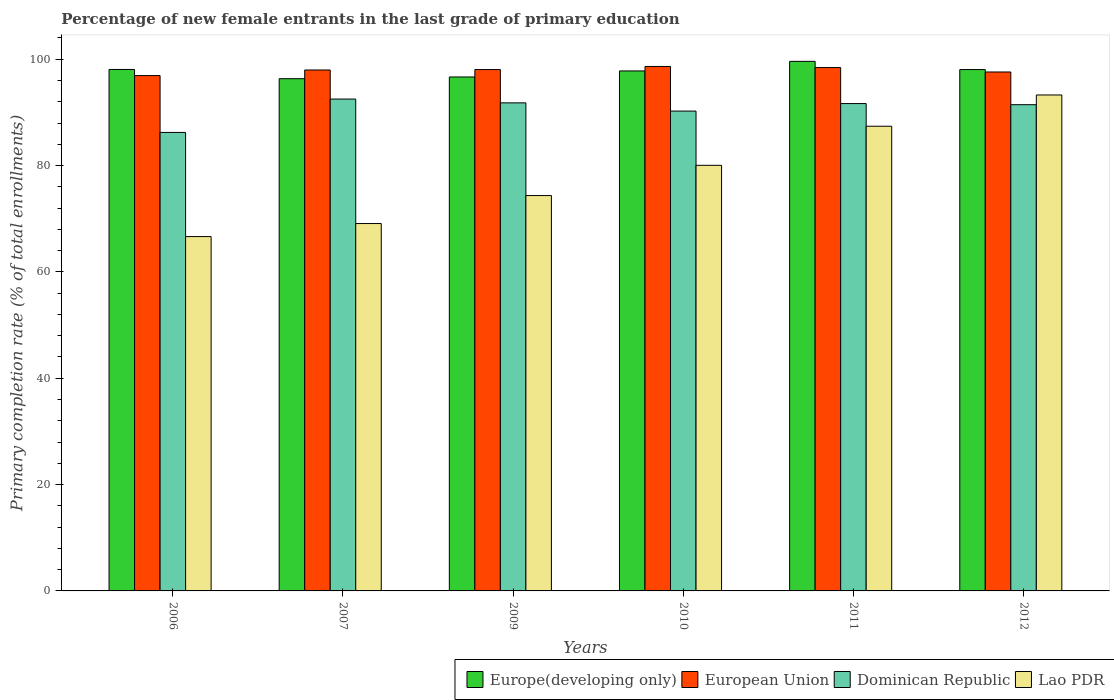How many different coloured bars are there?
Provide a succinct answer. 4. Are the number of bars on each tick of the X-axis equal?
Your response must be concise. Yes. What is the percentage of new female entrants in Lao PDR in 2007?
Ensure brevity in your answer.  69.09. Across all years, what is the maximum percentage of new female entrants in European Union?
Your response must be concise. 98.64. Across all years, what is the minimum percentage of new female entrants in European Union?
Your answer should be compact. 96.92. In which year was the percentage of new female entrants in Europe(developing only) maximum?
Make the answer very short. 2011. In which year was the percentage of new female entrants in Lao PDR minimum?
Give a very brief answer. 2006. What is the total percentage of new female entrants in Lao PDR in the graph?
Provide a succinct answer. 470.8. What is the difference between the percentage of new female entrants in Lao PDR in 2006 and that in 2011?
Give a very brief answer. -20.76. What is the difference between the percentage of new female entrants in European Union in 2011 and the percentage of new female entrants in Dominican Republic in 2012?
Your response must be concise. 6.98. What is the average percentage of new female entrants in Dominican Republic per year?
Offer a very short reply. 90.65. In the year 2007, what is the difference between the percentage of new female entrants in Europe(developing only) and percentage of new female entrants in Dominican Republic?
Your answer should be very brief. 3.83. What is the ratio of the percentage of new female entrants in Europe(developing only) in 2010 to that in 2011?
Ensure brevity in your answer.  0.98. What is the difference between the highest and the second highest percentage of new female entrants in Dominican Republic?
Provide a succinct answer. 0.72. What is the difference between the highest and the lowest percentage of new female entrants in Lao PDR?
Your answer should be compact. 26.63. In how many years, is the percentage of new female entrants in Dominican Republic greater than the average percentage of new female entrants in Dominican Republic taken over all years?
Offer a very short reply. 4. What does the 2nd bar from the left in 2006 represents?
Your answer should be compact. European Union. What does the 4th bar from the right in 2011 represents?
Provide a short and direct response. Europe(developing only). Is it the case that in every year, the sum of the percentage of new female entrants in Dominican Republic and percentage of new female entrants in Europe(developing only) is greater than the percentage of new female entrants in Lao PDR?
Provide a succinct answer. Yes. How many years are there in the graph?
Give a very brief answer. 6. Are the values on the major ticks of Y-axis written in scientific E-notation?
Your answer should be very brief. No. Does the graph contain any zero values?
Keep it short and to the point. No. Where does the legend appear in the graph?
Ensure brevity in your answer.  Bottom right. How are the legend labels stacked?
Provide a short and direct response. Horizontal. What is the title of the graph?
Provide a succinct answer. Percentage of new female entrants in the last grade of primary education. What is the label or title of the Y-axis?
Give a very brief answer. Primary completion rate (% of total enrollments). What is the Primary completion rate (% of total enrollments) of Europe(developing only) in 2006?
Keep it short and to the point. 98.07. What is the Primary completion rate (% of total enrollments) of European Union in 2006?
Your response must be concise. 96.92. What is the Primary completion rate (% of total enrollments) in Dominican Republic in 2006?
Your answer should be very brief. 86.23. What is the Primary completion rate (% of total enrollments) in Lao PDR in 2006?
Keep it short and to the point. 66.64. What is the Primary completion rate (% of total enrollments) of Europe(developing only) in 2007?
Your answer should be very brief. 96.34. What is the Primary completion rate (% of total enrollments) in European Union in 2007?
Your answer should be very brief. 97.97. What is the Primary completion rate (% of total enrollments) in Dominican Republic in 2007?
Offer a terse response. 92.51. What is the Primary completion rate (% of total enrollments) of Lao PDR in 2007?
Offer a terse response. 69.09. What is the Primary completion rate (% of total enrollments) in Europe(developing only) in 2009?
Give a very brief answer. 96.66. What is the Primary completion rate (% of total enrollments) of European Union in 2009?
Keep it short and to the point. 98.05. What is the Primary completion rate (% of total enrollments) in Dominican Republic in 2009?
Provide a succinct answer. 91.79. What is the Primary completion rate (% of total enrollments) in Lao PDR in 2009?
Provide a succinct answer. 74.35. What is the Primary completion rate (% of total enrollments) of Europe(developing only) in 2010?
Give a very brief answer. 97.79. What is the Primary completion rate (% of total enrollments) of European Union in 2010?
Make the answer very short. 98.64. What is the Primary completion rate (% of total enrollments) in Dominican Republic in 2010?
Your response must be concise. 90.25. What is the Primary completion rate (% of total enrollments) in Lao PDR in 2010?
Your answer should be very brief. 80.04. What is the Primary completion rate (% of total enrollments) in Europe(developing only) in 2011?
Your answer should be very brief. 99.6. What is the Primary completion rate (% of total enrollments) in European Union in 2011?
Provide a short and direct response. 98.43. What is the Primary completion rate (% of total enrollments) of Dominican Republic in 2011?
Ensure brevity in your answer.  91.66. What is the Primary completion rate (% of total enrollments) of Lao PDR in 2011?
Make the answer very short. 87.4. What is the Primary completion rate (% of total enrollments) of Europe(developing only) in 2012?
Ensure brevity in your answer.  98.05. What is the Primary completion rate (% of total enrollments) of European Union in 2012?
Keep it short and to the point. 97.6. What is the Primary completion rate (% of total enrollments) in Dominican Republic in 2012?
Your answer should be compact. 91.45. What is the Primary completion rate (% of total enrollments) of Lao PDR in 2012?
Offer a very short reply. 93.27. Across all years, what is the maximum Primary completion rate (% of total enrollments) in Europe(developing only)?
Offer a very short reply. 99.6. Across all years, what is the maximum Primary completion rate (% of total enrollments) in European Union?
Provide a succinct answer. 98.64. Across all years, what is the maximum Primary completion rate (% of total enrollments) of Dominican Republic?
Ensure brevity in your answer.  92.51. Across all years, what is the maximum Primary completion rate (% of total enrollments) in Lao PDR?
Your answer should be very brief. 93.27. Across all years, what is the minimum Primary completion rate (% of total enrollments) of Europe(developing only)?
Keep it short and to the point. 96.34. Across all years, what is the minimum Primary completion rate (% of total enrollments) in European Union?
Offer a terse response. 96.92. Across all years, what is the minimum Primary completion rate (% of total enrollments) of Dominican Republic?
Offer a very short reply. 86.23. Across all years, what is the minimum Primary completion rate (% of total enrollments) of Lao PDR?
Offer a very short reply. 66.64. What is the total Primary completion rate (% of total enrollments) of Europe(developing only) in the graph?
Offer a very short reply. 586.51. What is the total Primary completion rate (% of total enrollments) in European Union in the graph?
Make the answer very short. 587.61. What is the total Primary completion rate (% of total enrollments) of Dominican Republic in the graph?
Your answer should be very brief. 543.88. What is the total Primary completion rate (% of total enrollments) in Lao PDR in the graph?
Your answer should be compact. 470.8. What is the difference between the Primary completion rate (% of total enrollments) in Europe(developing only) in 2006 and that in 2007?
Your answer should be compact. 1.73. What is the difference between the Primary completion rate (% of total enrollments) of European Union in 2006 and that in 2007?
Ensure brevity in your answer.  -1.05. What is the difference between the Primary completion rate (% of total enrollments) of Dominican Republic in 2006 and that in 2007?
Offer a terse response. -6.28. What is the difference between the Primary completion rate (% of total enrollments) in Lao PDR in 2006 and that in 2007?
Keep it short and to the point. -2.45. What is the difference between the Primary completion rate (% of total enrollments) in Europe(developing only) in 2006 and that in 2009?
Provide a succinct answer. 1.41. What is the difference between the Primary completion rate (% of total enrollments) in European Union in 2006 and that in 2009?
Provide a short and direct response. -1.13. What is the difference between the Primary completion rate (% of total enrollments) of Dominican Republic in 2006 and that in 2009?
Your answer should be compact. -5.56. What is the difference between the Primary completion rate (% of total enrollments) in Lao PDR in 2006 and that in 2009?
Make the answer very short. -7.72. What is the difference between the Primary completion rate (% of total enrollments) in Europe(developing only) in 2006 and that in 2010?
Offer a very short reply. 0.28. What is the difference between the Primary completion rate (% of total enrollments) of European Union in 2006 and that in 2010?
Make the answer very short. -1.71. What is the difference between the Primary completion rate (% of total enrollments) of Dominican Republic in 2006 and that in 2010?
Provide a short and direct response. -4.01. What is the difference between the Primary completion rate (% of total enrollments) of Lao PDR in 2006 and that in 2010?
Make the answer very short. -13.41. What is the difference between the Primary completion rate (% of total enrollments) in Europe(developing only) in 2006 and that in 2011?
Give a very brief answer. -1.53. What is the difference between the Primary completion rate (% of total enrollments) in European Union in 2006 and that in 2011?
Keep it short and to the point. -1.51. What is the difference between the Primary completion rate (% of total enrollments) in Dominican Republic in 2006 and that in 2011?
Give a very brief answer. -5.43. What is the difference between the Primary completion rate (% of total enrollments) of Lao PDR in 2006 and that in 2011?
Your response must be concise. -20.76. What is the difference between the Primary completion rate (% of total enrollments) in Europe(developing only) in 2006 and that in 2012?
Ensure brevity in your answer.  0.02. What is the difference between the Primary completion rate (% of total enrollments) of European Union in 2006 and that in 2012?
Make the answer very short. -0.67. What is the difference between the Primary completion rate (% of total enrollments) of Dominican Republic in 2006 and that in 2012?
Provide a short and direct response. -5.21. What is the difference between the Primary completion rate (% of total enrollments) of Lao PDR in 2006 and that in 2012?
Ensure brevity in your answer.  -26.64. What is the difference between the Primary completion rate (% of total enrollments) of Europe(developing only) in 2007 and that in 2009?
Provide a short and direct response. -0.32. What is the difference between the Primary completion rate (% of total enrollments) in European Union in 2007 and that in 2009?
Offer a terse response. -0.08. What is the difference between the Primary completion rate (% of total enrollments) in Dominican Republic in 2007 and that in 2009?
Your response must be concise. 0.72. What is the difference between the Primary completion rate (% of total enrollments) of Lao PDR in 2007 and that in 2009?
Make the answer very short. -5.26. What is the difference between the Primary completion rate (% of total enrollments) in Europe(developing only) in 2007 and that in 2010?
Your answer should be compact. -1.46. What is the difference between the Primary completion rate (% of total enrollments) of European Union in 2007 and that in 2010?
Provide a succinct answer. -0.67. What is the difference between the Primary completion rate (% of total enrollments) of Dominican Republic in 2007 and that in 2010?
Your answer should be very brief. 2.26. What is the difference between the Primary completion rate (% of total enrollments) of Lao PDR in 2007 and that in 2010?
Your answer should be compact. -10.95. What is the difference between the Primary completion rate (% of total enrollments) of Europe(developing only) in 2007 and that in 2011?
Your answer should be very brief. -3.26. What is the difference between the Primary completion rate (% of total enrollments) in European Union in 2007 and that in 2011?
Offer a very short reply. -0.46. What is the difference between the Primary completion rate (% of total enrollments) in Dominican Republic in 2007 and that in 2011?
Offer a very short reply. 0.85. What is the difference between the Primary completion rate (% of total enrollments) in Lao PDR in 2007 and that in 2011?
Make the answer very short. -18.3. What is the difference between the Primary completion rate (% of total enrollments) in Europe(developing only) in 2007 and that in 2012?
Offer a very short reply. -1.72. What is the difference between the Primary completion rate (% of total enrollments) of European Union in 2007 and that in 2012?
Provide a short and direct response. 0.37. What is the difference between the Primary completion rate (% of total enrollments) in Dominican Republic in 2007 and that in 2012?
Offer a terse response. 1.06. What is the difference between the Primary completion rate (% of total enrollments) in Lao PDR in 2007 and that in 2012?
Your response must be concise. -24.18. What is the difference between the Primary completion rate (% of total enrollments) of Europe(developing only) in 2009 and that in 2010?
Provide a succinct answer. -1.13. What is the difference between the Primary completion rate (% of total enrollments) in European Union in 2009 and that in 2010?
Offer a terse response. -0.59. What is the difference between the Primary completion rate (% of total enrollments) in Dominican Republic in 2009 and that in 2010?
Your answer should be compact. 1.54. What is the difference between the Primary completion rate (% of total enrollments) in Lao PDR in 2009 and that in 2010?
Provide a short and direct response. -5.69. What is the difference between the Primary completion rate (% of total enrollments) in Europe(developing only) in 2009 and that in 2011?
Provide a succinct answer. -2.94. What is the difference between the Primary completion rate (% of total enrollments) of European Union in 2009 and that in 2011?
Offer a very short reply. -0.38. What is the difference between the Primary completion rate (% of total enrollments) in Dominican Republic in 2009 and that in 2011?
Your answer should be compact. 0.13. What is the difference between the Primary completion rate (% of total enrollments) of Lao PDR in 2009 and that in 2011?
Provide a succinct answer. -13.04. What is the difference between the Primary completion rate (% of total enrollments) of Europe(developing only) in 2009 and that in 2012?
Provide a short and direct response. -1.39. What is the difference between the Primary completion rate (% of total enrollments) of European Union in 2009 and that in 2012?
Keep it short and to the point. 0.45. What is the difference between the Primary completion rate (% of total enrollments) of Dominican Republic in 2009 and that in 2012?
Make the answer very short. 0.34. What is the difference between the Primary completion rate (% of total enrollments) in Lao PDR in 2009 and that in 2012?
Make the answer very short. -18.92. What is the difference between the Primary completion rate (% of total enrollments) of Europe(developing only) in 2010 and that in 2011?
Your answer should be compact. -1.81. What is the difference between the Primary completion rate (% of total enrollments) of European Union in 2010 and that in 2011?
Provide a short and direct response. 0.21. What is the difference between the Primary completion rate (% of total enrollments) of Dominican Republic in 2010 and that in 2011?
Offer a very short reply. -1.41. What is the difference between the Primary completion rate (% of total enrollments) of Lao PDR in 2010 and that in 2011?
Make the answer very short. -7.35. What is the difference between the Primary completion rate (% of total enrollments) in Europe(developing only) in 2010 and that in 2012?
Your answer should be very brief. -0.26. What is the difference between the Primary completion rate (% of total enrollments) of European Union in 2010 and that in 2012?
Keep it short and to the point. 1.04. What is the difference between the Primary completion rate (% of total enrollments) of Dominican Republic in 2010 and that in 2012?
Ensure brevity in your answer.  -1.2. What is the difference between the Primary completion rate (% of total enrollments) of Lao PDR in 2010 and that in 2012?
Your answer should be very brief. -13.23. What is the difference between the Primary completion rate (% of total enrollments) of Europe(developing only) in 2011 and that in 2012?
Give a very brief answer. 1.54. What is the difference between the Primary completion rate (% of total enrollments) of European Union in 2011 and that in 2012?
Your answer should be very brief. 0.83. What is the difference between the Primary completion rate (% of total enrollments) of Dominican Republic in 2011 and that in 2012?
Your response must be concise. 0.21. What is the difference between the Primary completion rate (% of total enrollments) in Lao PDR in 2011 and that in 2012?
Offer a terse response. -5.88. What is the difference between the Primary completion rate (% of total enrollments) of Europe(developing only) in 2006 and the Primary completion rate (% of total enrollments) of European Union in 2007?
Keep it short and to the point. 0.1. What is the difference between the Primary completion rate (% of total enrollments) in Europe(developing only) in 2006 and the Primary completion rate (% of total enrollments) in Dominican Republic in 2007?
Ensure brevity in your answer.  5.56. What is the difference between the Primary completion rate (% of total enrollments) in Europe(developing only) in 2006 and the Primary completion rate (% of total enrollments) in Lao PDR in 2007?
Your answer should be very brief. 28.98. What is the difference between the Primary completion rate (% of total enrollments) of European Union in 2006 and the Primary completion rate (% of total enrollments) of Dominican Republic in 2007?
Provide a short and direct response. 4.42. What is the difference between the Primary completion rate (% of total enrollments) of European Union in 2006 and the Primary completion rate (% of total enrollments) of Lao PDR in 2007?
Offer a very short reply. 27.83. What is the difference between the Primary completion rate (% of total enrollments) in Dominican Republic in 2006 and the Primary completion rate (% of total enrollments) in Lao PDR in 2007?
Make the answer very short. 17.14. What is the difference between the Primary completion rate (% of total enrollments) in Europe(developing only) in 2006 and the Primary completion rate (% of total enrollments) in European Union in 2009?
Ensure brevity in your answer.  0.02. What is the difference between the Primary completion rate (% of total enrollments) of Europe(developing only) in 2006 and the Primary completion rate (% of total enrollments) of Dominican Republic in 2009?
Make the answer very short. 6.28. What is the difference between the Primary completion rate (% of total enrollments) in Europe(developing only) in 2006 and the Primary completion rate (% of total enrollments) in Lao PDR in 2009?
Provide a short and direct response. 23.72. What is the difference between the Primary completion rate (% of total enrollments) in European Union in 2006 and the Primary completion rate (% of total enrollments) in Dominican Republic in 2009?
Offer a very short reply. 5.13. What is the difference between the Primary completion rate (% of total enrollments) of European Union in 2006 and the Primary completion rate (% of total enrollments) of Lao PDR in 2009?
Ensure brevity in your answer.  22.57. What is the difference between the Primary completion rate (% of total enrollments) in Dominican Republic in 2006 and the Primary completion rate (% of total enrollments) in Lao PDR in 2009?
Offer a terse response. 11.88. What is the difference between the Primary completion rate (% of total enrollments) in Europe(developing only) in 2006 and the Primary completion rate (% of total enrollments) in European Union in 2010?
Provide a succinct answer. -0.57. What is the difference between the Primary completion rate (% of total enrollments) of Europe(developing only) in 2006 and the Primary completion rate (% of total enrollments) of Dominican Republic in 2010?
Give a very brief answer. 7.83. What is the difference between the Primary completion rate (% of total enrollments) of Europe(developing only) in 2006 and the Primary completion rate (% of total enrollments) of Lao PDR in 2010?
Give a very brief answer. 18.03. What is the difference between the Primary completion rate (% of total enrollments) in European Union in 2006 and the Primary completion rate (% of total enrollments) in Dominican Republic in 2010?
Keep it short and to the point. 6.68. What is the difference between the Primary completion rate (% of total enrollments) in European Union in 2006 and the Primary completion rate (% of total enrollments) in Lao PDR in 2010?
Your answer should be very brief. 16.88. What is the difference between the Primary completion rate (% of total enrollments) of Dominican Republic in 2006 and the Primary completion rate (% of total enrollments) of Lao PDR in 2010?
Your answer should be very brief. 6.19. What is the difference between the Primary completion rate (% of total enrollments) of Europe(developing only) in 2006 and the Primary completion rate (% of total enrollments) of European Union in 2011?
Offer a terse response. -0.36. What is the difference between the Primary completion rate (% of total enrollments) in Europe(developing only) in 2006 and the Primary completion rate (% of total enrollments) in Dominican Republic in 2011?
Offer a terse response. 6.41. What is the difference between the Primary completion rate (% of total enrollments) in Europe(developing only) in 2006 and the Primary completion rate (% of total enrollments) in Lao PDR in 2011?
Ensure brevity in your answer.  10.68. What is the difference between the Primary completion rate (% of total enrollments) of European Union in 2006 and the Primary completion rate (% of total enrollments) of Dominican Republic in 2011?
Give a very brief answer. 5.27. What is the difference between the Primary completion rate (% of total enrollments) of European Union in 2006 and the Primary completion rate (% of total enrollments) of Lao PDR in 2011?
Ensure brevity in your answer.  9.53. What is the difference between the Primary completion rate (% of total enrollments) of Dominican Republic in 2006 and the Primary completion rate (% of total enrollments) of Lao PDR in 2011?
Keep it short and to the point. -1.16. What is the difference between the Primary completion rate (% of total enrollments) in Europe(developing only) in 2006 and the Primary completion rate (% of total enrollments) in European Union in 2012?
Provide a short and direct response. 0.47. What is the difference between the Primary completion rate (% of total enrollments) in Europe(developing only) in 2006 and the Primary completion rate (% of total enrollments) in Dominican Republic in 2012?
Ensure brevity in your answer.  6.62. What is the difference between the Primary completion rate (% of total enrollments) in Europe(developing only) in 2006 and the Primary completion rate (% of total enrollments) in Lao PDR in 2012?
Provide a short and direct response. 4.8. What is the difference between the Primary completion rate (% of total enrollments) of European Union in 2006 and the Primary completion rate (% of total enrollments) of Dominican Republic in 2012?
Provide a succinct answer. 5.48. What is the difference between the Primary completion rate (% of total enrollments) in European Union in 2006 and the Primary completion rate (% of total enrollments) in Lao PDR in 2012?
Your answer should be compact. 3.65. What is the difference between the Primary completion rate (% of total enrollments) in Dominican Republic in 2006 and the Primary completion rate (% of total enrollments) in Lao PDR in 2012?
Offer a very short reply. -7.04. What is the difference between the Primary completion rate (% of total enrollments) of Europe(developing only) in 2007 and the Primary completion rate (% of total enrollments) of European Union in 2009?
Provide a succinct answer. -1.71. What is the difference between the Primary completion rate (% of total enrollments) of Europe(developing only) in 2007 and the Primary completion rate (% of total enrollments) of Dominican Republic in 2009?
Provide a short and direct response. 4.55. What is the difference between the Primary completion rate (% of total enrollments) in Europe(developing only) in 2007 and the Primary completion rate (% of total enrollments) in Lao PDR in 2009?
Ensure brevity in your answer.  21.98. What is the difference between the Primary completion rate (% of total enrollments) in European Union in 2007 and the Primary completion rate (% of total enrollments) in Dominican Republic in 2009?
Your answer should be compact. 6.18. What is the difference between the Primary completion rate (% of total enrollments) in European Union in 2007 and the Primary completion rate (% of total enrollments) in Lao PDR in 2009?
Your answer should be compact. 23.62. What is the difference between the Primary completion rate (% of total enrollments) of Dominican Republic in 2007 and the Primary completion rate (% of total enrollments) of Lao PDR in 2009?
Keep it short and to the point. 18.15. What is the difference between the Primary completion rate (% of total enrollments) of Europe(developing only) in 2007 and the Primary completion rate (% of total enrollments) of European Union in 2010?
Ensure brevity in your answer.  -2.3. What is the difference between the Primary completion rate (% of total enrollments) of Europe(developing only) in 2007 and the Primary completion rate (% of total enrollments) of Dominican Republic in 2010?
Your answer should be very brief. 6.09. What is the difference between the Primary completion rate (% of total enrollments) in Europe(developing only) in 2007 and the Primary completion rate (% of total enrollments) in Lao PDR in 2010?
Give a very brief answer. 16.29. What is the difference between the Primary completion rate (% of total enrollments) of European Union in 2007 and the Primary completion rate (% of total enrollments) of Dominican Republic in 2010?
Your answer should be very brief. 7.73. What is the difference between the Primary completion rate (% of total enrollments) of European Union in 2007 and the Primary completion rate (% of total enrollments) of Lao PDR in 2010?
Give a very brief answer. 17.93. What is the difference between the Primary completion rate (% of total enrollments) of Dominican Republic in 2007 and the Primary completion rate (% of total enrollments) of Lao PDR in 2010?
Provide a short and direct response. 12.46. What is the difference between the Primary completion rate (% of total enrollments) in Europe(developing only) in 2007 and the Primary completion rate (% of total enrollments) in European Union in 2011?
Provide a succinct answer. -2.09. What is the difference between the Primary completion rate (% of total enrollments) in Europe(developing only) in 2007 and the Primary completion rate (% of total enrollments) in Dominican Republic in 2011?
Give a very brief answer. 4.68. What is the difference between the Primary completion rate (% of total enrollments) of Europe(developing only) in 2007 and the Primary completion rate (% of total enrollments) of Lao PDR in 2011?
Provide a short and direct response. 8.94. What is the difference between the Primary completion rate (% of total enrollments) of European Union in 2007 and the Primary completion rate (% of total enrollments) of Dominican Republic in 2011?
Your response must be concise. 6.31. What is the difference between the Primary completion rate (% of total enrollments) of European Union in 2007 and the Primary completion rate (% of total enrollments) of Lao PDR in 2011?
Provide a short and direct response. 10.58. What is the difference between the Primary completion rate (% of total enrollments) of Dominican Republic in 2007 and the Primary completion rate (% of total enrollments) of Lao PDR in 2011?
Make the answer very short. 5.11. What is the difference between the Primary completion rate (% of total enrollments) of Europe(developing only) in 2007 and the Primary completion rate (% of total enrollments) of European Union in 2012?
Your answer should be compact. -1.26. What is the difference between the Primary completion rate (% of total enrollments) of Europe(developing only) in 2007 and the Primary completion rate (% of total enrollments) of Dominican Republic in 2012?
Offer a terse response. 4.89. What is the difference between the Primary completion rate (% of total enrollments) in Europe(developing only) in 2007 and the Primary completion rate (% of total enrollments) in Lao PDR in 2012?
Keep it short and to the point. 3.06. What is the difference between the Primary completion rate (% of total enrollments) in European Union in 2007 and the Primary completion rate (% of total enrollments) in Dominican Republic in 2012?
Your answer should be very brief. 6.53. What is the difference between the Primary completion rate (% of total enrollments) in European Union in 2007 and the Primary completion rate (% of total enrollments) in Lao PDR in 2012?
Give a very brief answer. 4.7. What is the difference between the Primary completion rate (% of total enrollments) of Dominican Republic in 2007 and the Primary completion rate (% of total enrollments) of Lao PDR in 2012?
Provide a succinct answer. -0.77. What is the difference between the Primary completion rate (% of total enrollments) of Europe(developing only) in 2009 and the Primary completion rate (% of total enrollments) of European Union in 2010?
Your response must be concise. -1.98. What is the difference between the Primary completion rate (% of total enrollments) of Europe(developing only) in 2009 and the Primary completion rate (% of total enrollments) of Dominican Republic in 2010?
Your answer should be very brief. 6.41. What is the difference between the Primary completion rate (% of total enrollments) in Europe(developing only) in 2009 and the Primary completion rate (% of total enrollments) in Lao PDR in 2010?
Keep it short and to the point. 16.61. What is the difference between the Primary completion rate (% of total enrollments) of European Union in 2009 and the Primary completion rate (% of total enrollments) of Dominican Republic in 2010?
Your response must be concise. 7.81. What is the difference between the Primary completion rate (% of total enrollments) of European Union in 2009 and the Primary completion rate (% of total enrollments) of Lao PDR in 2010?
Provide a short and direct response. 18.01. What is the difference between the Primary completion rate (% of total enrollments) in Dominican Republic in 2009 and the Primary completion rate (% of total enrollments) in Lao PDR in 2010?
Your answer should be compact. 11.74. What is the difference between the Primary completion rate (% of total enrollments) of Europe(developing only) in 2009 and the Primary completion rate (% of total enrollments) of European Union in 2011?
Your response must be concise. -1.77. What is the difference between the Primary completion rate (% of total enrollments) of Europe(developing only) in 2009 and the Primary completion rate (% of total enrollments) of Dominican Republic in 2011?
Offer a very short reply. 5. What is the difference between the Primary completion rate (% of total enrollments) in Europe(developing only) in 2009 and the Primary completion rate (% of total enrollments) in Lao PDR in 2011?
Ensure brevity in your answer.  9.26. What is the difference between the Primary completion rate (% of total enrollments) in European Union in 2009 and the Primary completion rate (% of total enrollments) in Dominican Republic in 2011?
Your answer should be very brief. 6.39. What is the difference between the Primary completion rate (% of total enrollments) of European Union in 2009 and the Primary completion rate (% of total enrollments) of Lao PDR in 2011?
Your answer should be compact. 10.66. What is the difference between the Primary completion rate (% of total enrollments) in Dominican Republic in 2009 and the Primary completion rate (% of total enrollments) in Lao PDR in 2011?
Your response must be concise. 4.39. What is the difference between the Primary completion rate (% of total enrollments) of Europe(developing only) in 2009 and the Primary completion rate (% of total enrollments) of European Union in 2012?
Offer a very short reply. -0.94. What is the difference between the Primary completion rate (% of total enrollments) in Europe(developing only) in 2009 and the Primary completion rate (% of total enrollments) in Dominican Republic in 2012?
Offer a very short reply. 5.21. What is the difference between the Primary completion rate (% of total enrollments) in Europe(developing only) in 2009 and the Primary completion rate (% of total enrollments) in Lao PDR in 2012?
Keep it short and to the point. 3.38. What is the difference between the Primary completion rate (% of total enrollments) in European Union in 2009 and the Primary completion rate (% of total enrollments) in Dominican Republic in 2012?
Offer a very short reply. 6.61. What is the difference between the Primary completion rate (% of total enrollments) in European Union in 2009 and the Primary completion rate (% of total enrollments) in Lao PDR in 2012?
Your answer should be compact. 4.78. What is the difference between the Primary completion rate (% of total enrollments) in Dominican Republic in 2009 and the Primary completion rate (% of total enrollments) in Lao PDR in 2012?
Offer a very short reply. -1.49. What is the difference between the Primary completion rate (% of total enrollments) in Europe(developing only) in 2010 and the Primary completion rate (% of total enrollments) in European Union in 2011?
Your answer should be compact. -0.64. What is the difference between the Primary completion rate (% of total enrollments) in Europe(developing only) in 2010 and the Primary completion rate (% of total enrollments) in Dominican Republic in 2011?
Make the answer very short. 6.13. What is the difference between the Primary completion rate (% of total enrollments) in Europe(developing only) in 2010 and the Primary completion rate (% of total enrollments) in Lao PDR in 2011?
Your answer should be very brief. 10.4. What is the difference between the Primary completion rate (% of total enrollments) in European Union in 2010 and the Primary completion rate (% of total enrollments) in Dominican Republic in 2011?
Your response must be concise. 6.98. What is the difference between the Primary completion rate (% of total enrollments) in European Union in 2010 and the Primary completion rate (% of total enrollments) in Lao PDR in 2011?
Provide a succinct answer. 11.24. What is the difference between the Primary completion rate (% of total enrollments) of Dominican Republic in 2010 and the Primary completion rate (% of total enrollments) of Lao PDR in 2011?
Offer a terse response. 2.85. What is the difference between the Primary completion rate (% of total enrollments) of Europe(developing only) in 2010 and the Primary completion rate (% of total enrollments) of European Union in 2012?
Your answer should be very brief. 0.19. What is the difference between the Primary completion rate (% of total enrollments) of Europe(developing only) in 2010 and the Primary completion rate (% of total enrollments) of Dominican Republic in 2012?
Provide a short and direct response. 6.35. What is the difference between the Primary completion rate (% of total enrollments) of Europe(developing only) in 2010 and the Primary completion rate (% of total enrollments) of Lao PDR in 2012?
Make the answer very short. 4.52. What is the difference between the Primary completion rate (% of total enrollments) of European Union in 2010 and the Primary completion rate (% of total enrollments) of Dominican Republic in 2012?
Your answer should be very brief. 7.19. What is the difference between the Primary completion rate (% of total enrollments) in European Union in 2010 and the Primary completion rate (% of total enrollments) in Lao PDR in 2012?
Your response must be concise. 5.36. What is the difference between the Primary completion rate (% of total enrollments) in Dominican Republic in 2010 and the Primary completion rate (% of total enrollments) in Lao PDR in 2012?
Your response must be concise. -3.03. What is the difference between the Primary completion rate (% of total enrollments) in Europe(developing only) in 2011 and the Primary completion rate (% of total enrollments) in European Union in 2012?
Provide a succinct answer. 2. What is the difference between the Primary completion rate (% of total enrollments) of Europe(developing only) in 2011 and the Primary completion rate (% of total enrollments) of Dominican Republic in 2012?
Give a very brief answer. 8.15. What is the difference between the Primary completion rate (% of total enrollments) of Europe(developing only) in 2011 and the Primary completion rate (% of total enrollments) of Lao PDR in 2012?
Provide a succinct answer. 6.32. What is the difference between the Primary completion rate (% of total enrollments) in European Union in 2011 and the Primary completion rate (% of total enrollments) in Dominican Republic in 2012?
Your answer should be very brief. 6.98. What is the difference between the Primary completion rate (% of total enrollments) of European Union in 2011 and the Primary completion rate (% of total enrollments) of Lao PDR in 2012?
Give a very brief answer. 5.16. What is the difference between the Primary completion rate (% of total enrollments) in Dominican Republic in 2011 and the Primary completion rate (% of total enrollments) in Lao PDR in 2012?
Offer a very short reply. -1.62. What is the average Primary completion rate (% of total enrollments) of Europe(developing only) per year?
Offer a terse response. 97.75. What is the average Primary completion rate (% of total enrollments) of European Union per year?
Give a very brief answer. 97.94. What is the average Primary completion rate (% of total enrollments) in Dominican Republic per year?
Your answer should be compact. 90.65. What is the average Primary completion rate (% of total enrollments) of Lao PDR per year?
Make the answer very short. 78.47. In the year 2006, what is the difference between the Primary completion rate (% of total enrollments) of Europe(developing only) and Primary completion rate (% of total enrollments) of European Union?
Your answer should be very brief. 1.15. In the year 2006, what is the difference between the Primary completion rate (% of total enrollments) of Europe(developing only) and Primary completion rate (% of total enrollments) of Dominican Republic?
Offer a terse response. 11.84. In the year 2006, what is the difference between the Primary completion rate (% of total enrollments) of Europe(developing only) and Primary completion rate (% of total enrollments) of Lao PDR?
Provide a short and direct response. 31.43. In the year 2006, what is the difference between the Primary completion rate (% of total enrollments) of European Union and Primary completion rate (% of total enrollments) of Dominican Republic?
Your response must be concise. 10.69. In the year 2006, what is the difference between the Primary completion rate (% of total enrollments) in European Union and Primary completion rate (% of total enrollments) in Lao PDR?
Your response must be concise. 30.28. In the year 2006, what is the difference between the Primary completion rate (% of total enrollments) in Dominican Republic and Primary completion rate (% of total enrollments) in Lao PDR?
Ensure brevity in your answer.  19.59. In the year 2007, what is the difference between the Primary completion rate (% of total enrollments) in Europe(developing only) and Primary completion rate (% of total enrollments) in European Union?
Provide a succinct answer. -1.64. In the year 2007, what is the difference between the Primary completion rate (% of total enrollments) of Europe(developing only) and Primary completion rate (% of total enrollments) of Dominican Republic?
Your response must be concise. 3.83. In the year 2007, what is the difference between the Primary completion rate (% of total enrollments) in Europe(developing only) and Primary completion rate (% of total enrollments) in Lao PDR?
Keep it short and to the point. 27.24. In the year 2007, what is the difference between the Primary completion rate (% of total enrollments) in European Union and Primary completion rate (% of total enrollments) in Dominican Republic?
Give a very brief answer. 5.46. In the year 2007, what is the difference between the Primary completion rate (% of total enrollments) in European Union and Primary completion rate (% of total enrollments) in Lao PDR?
Give a very brief answer. 28.88. In the year 2007, what is the difference between the Primary completion rate (% of total enrollments) in Dominican Republic and Primary completion rate (% of total enrollments) in Lao PDR?
Make the answer very short. 23.41. In the year 2009, what is the difference between the Primary completion rate (% of total enrollments) of Europe(developing only) and Primary completion rate (% of total enrollments) of European Union?
Offer a terse response. -1.39. In the year 2009, what is the difference between the Primary completion rate (% of total enrollments) in Europe(developing only) and Primary completion rate (% of total enrollments) in Dominican Republic?
Offer a terse response. 4.87. In the year 2009, what is the difference between the Primary completion rate (% of total enrollments) of Europe(developing only) and Primary completion rate (% of total enrollments) of Lao PDR?
Ensure brevity in your answer.  22.3. In the year 2009, what is the difference between the Primary completion rate (% of total enrollments) in European Union and Primary completion rate (% of total enrollments) in Dominican Republic?
Offer a very short reply. 6.26. In the year 2009, what is the difference between the Primary completion rate (% of total enrollments) in European Union and Primary completion rate (% of total enrollments) in Lao PDR?
Make the answer very short. 23.7. In the year 2009, what is the difference between the Primary completion rate (% of total enrollments) in Dominican Republic and Primary completion rate (% of total enrollments) in Lao PDR?
Provide a short and direct response. 17.43. In the year 2010, what is the difference between the Primary completion rate (% of total enrollments) of Europe(developing only) and Primary completion rate (% of total enrollments) of European Union?
Your response must be concise. -0.85. In the year 2010, what is the difference between the Primary completion rate (% of total enrollments) of Europe(developing only) and Primary completion rate (% of total enrollments) of Dominican Republic?
Provide a succinct answer. 7.55. In the year 2010, what is the difference between the Primary completion rate (% of total enrollments) of Europe(developing only) and Primary completion rate (% of total enrollments) of Lao PDR?
Your answer should be compact. 17.75. In the year 2010, what is the difference between the Primary completion rate (% of total enrollments) in European Union and Primary completion rate (% of total enrollments) in Dominican Republic?
Your answer should be very brief. 8.39. In the year 2010, what is the difference between the Primary completion rate (% of total enrollments) in European Union and Primary completion rate (% of total enrollments) in Lao PDR?
Keep it short and to the point. 18.59. In the year 2010, what is the difference between the Primary completion rate (% of total enrollments) in Dominican Republic and Primary completion rate (% of total enrollments) in Lao PDR?
Make the answer very short. 10.2. In the year 2011, what is the difference between the Primary completion rate (% of total enrollments) in Europe(developing only) and Primary completion rate (% of total enrollments) in European Union?
Your answer should be very brief. 1.17. In the year 2011, what is the difference between the Primary completion rate (% of total enrollments) in Europe(developing only) and Primary completion rate (% of total enrollments) in Dominican Republic?
Your response must be concise. 7.94. In the year 2011, what is the difference between the Primary completion rate (% of total enrollments) in Europe(developing only) and Primary completion rate (% of total enrollments) in Lao PDR?
Give a very brief answer. 12.2. In the year 2011, what is the difference between the Primary completion rate (% of total enrollments) of European Union and Primary completion rate (% of total enrollments) of Dominican Republic?
Offer a terse response. 6.77. In the year 2011, what is the difference between the Primary completion rate (% of total enrollments) of European Union and Primary completion rate (% of total enrollments) of Lao PDR?
Your answer should be compact. 11.04. In the year 2011, what is the difference between the Primary completion rate (% of total enrollments) in Dominican Republic and Primary completion rate (% of total enrollments) in Lao PDR?
Ensure brevity in your answer.  4.26. In the year 2012, what is the difference between the Primary completion rate (% of total enrollments) of Europe(developing only) and Primary completion rate (% of total enrollments) of European Union?
Your answer should be very brief. 0.46. In the year 2012, what is the difference between the Primary completion rate (% of total enrollments) of Europe(developing only) and Primary completion rate (% of total enrollments) of Dominican Republic?
Ensure brevity in your answer.  6.61. In the year 2012, what is the difference between the Primary completion rate (% of total enrollments) in Europe(developing only) and Primary completion rate (% of total enrollments) in Lao PDR?
Keep it short and to the point. 4.78. In the year 2012, what is the difference between the Primary completion rate (% of total enrollments) of European Union and Primary completion rate (% of total enrollments) of Dominican Republic?
Make the answer very short. 6.15. In the year 2012, what is the difference between the Primary completion rate (% of total enrollments) in European Union and Primary completion rate (% of total enrollments) in Lao PDR?
Make the answer very short. 4.32. In the year 2012, what is the difference between the Primary completion rate (% of total enrollments) of Dominican Republic and Primary completion rate (% of total enrollments) of Lao PDR?
Your answer should be compact. -1.83. What is the ratio of the Primary completion rate (% of total enrollments) of Europe(developing only) in 2006 to that in 2007?
Offer a very short reply. 1.02. What is the ratio of the Primary completion rate (% of total enrollments) of European Union in 2006 to that in 2007?
Your response must be concise. 0.99. What is the ratio of the Primary completion rate (% of total enrollments) in Dominican Republic in 2006 to that in 2007?
Keep it short and to the point. 0.93. What is the ratio of the Primary completion rate (% of total enrollments) in Lao PDR in 2006 to that in 2007?
Provide a succinct answer. 0.96. What is the ratio of the Primary completion rate (% of total enrollments) in Europe(developing only) in 2006 to that in 2009?
Offer a terse response. 1.01. What is the ratio of the Primary completion rate (% of total enrollments) of Dominican Republic in 2006 to that in 2009?
Keep it short and to the point. 0.94. What is the ratio of the Primary completion rate (% of total enrollments) in Lao PDR in 2006 to that in 2009?
Offer a very short reply. 0.9. What is the ratio of the Primary completion rate (% of total enrollments) of European Union in 2006 to that in 2010?
Provide a succinct answer. 0.98. What is the ratio of the Primary completion rate (% of total enrollments) of Dominican Republic in 2006 to that in 2010?
Provide a short and direct response. 0.96. What is the ratio of the Primary completion rate (% of total enrollments) of Lao PDR in 2006 to that in 2010?
Ensure brevity in your answer.  0.83. What is the ratio of the Primary completion rate (% of total enrollments) of Europe(developing only) in 2006 to that in 2011?
Make the answer very short. 0.98. What is the ratio of the Primary completion rate (% of total enrollments) in European Union in 2006 to that in 2011?
Provide a succinct answer. 0.98. What is the ratio of the Primary completion rate (% of total enrollments) of Dominican Republic in 2006 to that in 2011?
Offer a very short reply. 0.94. What is the ratio of the Primary completion rate (% of total enrollments) of Lao PDR in 2006 to that in 2011?
Your answer should be compact. 0.76. What is the ratio of the Primary completion rate (% of total enrollments) of Dominican Republic in 2006 to that in 2012?
Provide a short and direct response. 0.94. What is the ratio of the Primary completion rate (% of total enrollments) in Lao PDR in 2006 to that in 2012?
Your answer should be compact. 0.71. What is the ratio of the Primary completion rate (% of total enrollments) in Europe(developing only) in 2007 to that in 2009?
Make the answer very short. 1. What is the ratio of the Primary completion rate (% of total enrollments) in Lao PDR in 2007 to that in 2009?
Offer a terse response. 0.93. What is the ratio of the Primary completion rate (% of total enrollments) of Europe(developing only) in 2007 to that in 2010?
Offer a very short reply. 0.99. What is the ratio of the Primary completion rate (% of total enrollments) in Dominican Republic in 2007 to that in 2010?
Offer a very short reply. 1.03. What is the ratio of the Primary completion rate (% of total enrollments) of Lao PDR in 2007 to that in 2010?
Give a very brief answer. 0.86. What is the ratio of the Primary completion rate (% of total enrollments) in Europe(developing only) in 2007 to that in 2011?
Keep it short and to the point. 0.97. What is the ratio of the Primary completion rate (% of total enrollments) in Dominican Republic in 2007 to that in 2011?
Provide a short and direct response. 1.01. What is the ratio of the Primary completion rate (% of total enrollments) in Lao PDR in 2007 to that in 2011?
Make the answer very short. 0.79. What is the ratio of the Primary completion rate (% of total enrollments) in Europe(developing only) in 2007 to that in 2012?
Ensure brevity in your answer.  0.98. What is the ratio of the Primary completion rate (% of total enrollments) in Dominican Republic in 2007 to that in 2012?
Ensure brevity in your answer.  1.01. What is the ratio of the Primary completion rate (% of total enrollments) of Lao PDR in 2007 to that in 2012?
Give a very brief answer. 0.74. What is the ratio of the Primary completion rate (% of total enrollments) of Europe(developing only) in 2009 to that in 2010?
Your answer should be compact. 0.99. What is the ratio of the Primary completion rate (% of total enrollments) of Dominican Republic in 2009 to that in 2010?
Offer a very short reply. 1.02. What is the ratio of the Primary completion rate (% of total enrollments) of Lao PDR in 2009 to that in 2010?
Provide a short and direct response. 0.93. What is the ratio of the Primary completion rate (% of total enrollments) of Europe(developing only) in 2009 to that in 2011?
Provide a short and direct response. 0.97. What is the ratio of the Primary completion rate (% of total enrollments) of European Union in 2009 to that in 2011?
Offer a terse response. 1. What is the ratio of the Primary completion rate (% of total enrollments) of Lao PDR in 2009 to that in 2011?
Provide a short and direct response. 0.85. What is the ratio of the Primary completion rate (% of total enrollments) in Europe(developing only) in 2009 to that in 2012?
Offer a very short reply. 0.99. What is the ratio of the Primary completion rate (% of total enrollments) of Dominican Republic in 2009 to that in 2012?
Provide a short and direct response. 1. What is the ratio of the Primary completion rate (% of total enrollments) of Lao PDR in 2009 to that in 2012?
Provide a short and direct response. 0.8. What is the ratio of the Primary completion rate (% of total enrollments) of Europe(developing only) in 2010 to that in 2011?
Provide a short and direct response. 0.98. What is the ratio of the Primary completion rate (% of total enrollments) in European Union in 2010 to that in 2011?
Keep it short and to the point. 1. What is the ratio of the Primary completion rate (% of total enrollments) of Dominican Republic in 2010 to that in 2011?
Provide a short and direct response. 0.98. What is the ratio of the Primary completion rate (% of total enrollments) in Lao PDR in 2010 to that in 2011?
Offer a terse response. 0.92. What is the ratio of the Primary completion rate (% of total enrollments) of European Union in 2010 to that in 2012?
Your answer should be very brief. 1.01. What is the ratio of the Primary completion rate (% of total enrollments) in Dominican Republic in 2010 to that in 2012?
Provide a short and direct response. 0.99. What is the ratio of the Primary completion rate (% of total enrollments) of Lao PDR in 2010 to that in 2012?
Make the answer very short. 0.86. What is the ratio of the Primary completion rate (% of total enrollments) of Europe(developing only) in 2011 to that in 2012?
Provide a succinct answer. 1.02. What is the ratio of the Primary completion rate (% of total enrollments) of European Union in 2011 to that in 2012?
Your answer should be very brief. 1.01. What is the ratio of the Primary completion rate (% of total enrollments) of Dominican Republic in 2011 to that in 2012?
Your answer should be compact. 1. What is the ratio of the Primary completion rate (% of total enrollments) of Lao PDR in 2011 to that in 2012?
Provide a succinct answer. 0.94. What is the difference between the highest and the second highest Primary completion rate (% of total enrollments) in Europe(developing only)?
Offer a very short reply. 1.53. What is the difference between the highest and the second highest Primary completion rate (% of total enrollments) in European Union?
Your response must be concise. 0.21. What is the difference between the highest and the second highest Primary completion rate (% of total enrollments) of Dominican Republic?
Ensure brevity in your answer.  0.72. What is the difference between the highest and the second highest Primary completion rate (% of total enrollments) in Lao PDR?
Provide a succinct answer. 5.88. What is the difference between the highest and the lowest Primary completion rate (% of total enrollments) of Europe(developing only)?
Give a very brief answer. 3.26. What is the difference between the highest and the lowest Primary completion rate (% of total enrollments) of European Union?
Your answer should be very brief. 1.71. What is the difference between the highest and the lowest Primary completion rate (% of total enrollments) of Dominican Republic?
Make the answer very short. 6.28. What is the difference between the highest and the lowest Primary completion rate (% of total enrollments) in Lao PDR?
Offer a very short reply. 26.64. 